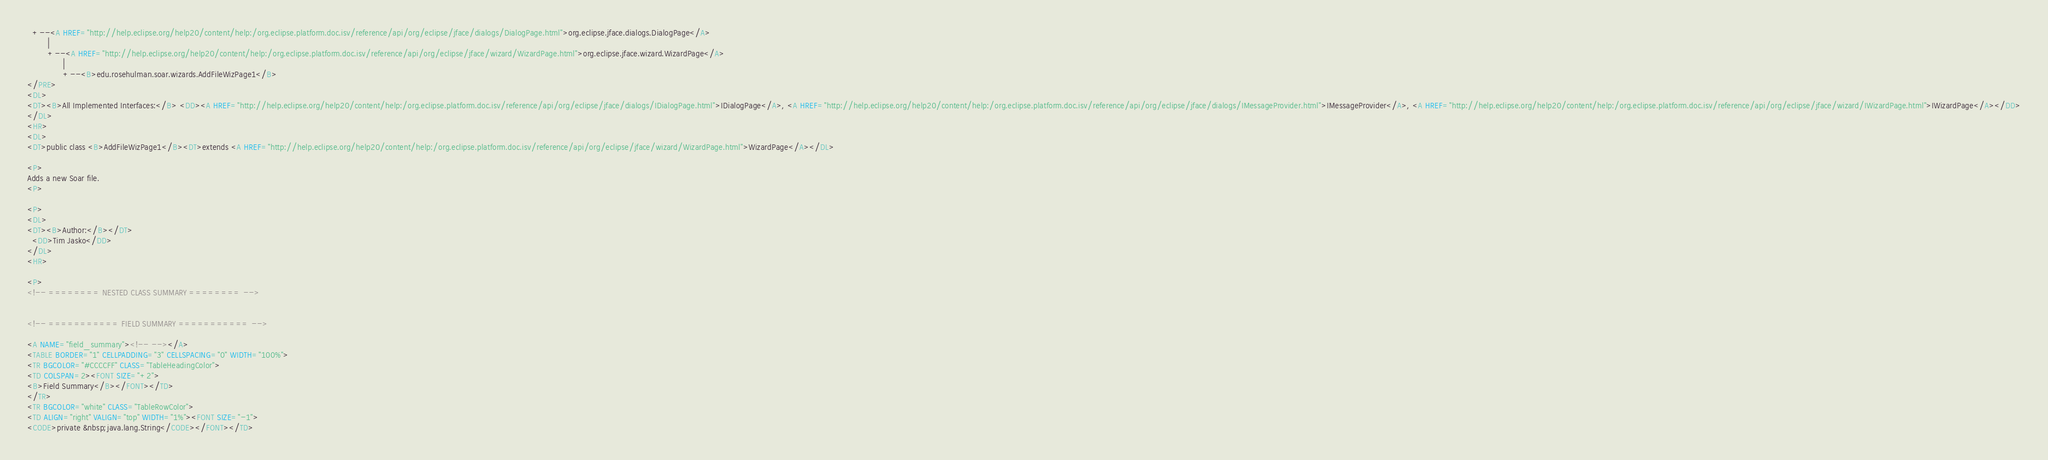<code> <loc_0><loc_0><loc_500><loc_500><_HTML_>  +--<A HREF="http://help.eclipse.org/help20/content/help:/org.eclipse.platform.doc.isv/reference/api/org/eclipse/jface/dialogs/DialogPage.html">org.eclipse.jface.dialogs.DialogPage</A>
        |
        +--<A HREF="http://help.eclipse.org/help20/content/help:/org.eclipse.platform.doc.isv/reference/api/org/eclipse/jface/wizard/WizardPage.html">org.eclipse.jface.wizard.WizardPage</A>
              |
              +--<B>edu.rosehulman.soar.wizards.AddFileWizPage1</B>
</PRE>
<DL>
<DT><B>All Implemented Interfaces:</B> <DD><A HREF="http://help.eclipse.org/help20/content/help:/org.eclipse.platform.doc.isv/reference/api/org/eclipse/jface/dialogs/IDialogPage.html">IDialogPage</A>, <A HREF="http://help.eclipse.org/help20/content/help:/org.eclipse.platform.doc.isv/reference/api/org/eclipse/jface/dialogs/IMessageProvider.html">IMessageProvider</A>, <A HREF="http://help.eclipse.org/help20/content/help:/org.eclipse.platform.doc.isv/reference/api/org/eclipse/jface/wizard/IWizardPage.html">IWizardPage</A></DD>
</DL>
<HR>
<DL>
<DT>public class <B>AddFileWizPage1</B><DT>extends <A HREF="http://help.eclipse.org/help20/content/help:/org.eclipse.platform.doc.isv/reference/api/org/eclipse/jface/wizard/WizardPage.html">WizardPage</A></DL>

<P>
Adds a new Soar file.
<P>

<P>
<DL>
<DT><B>Author:</B></DT>
  <DD>Tim Jasko</DD>
</DL>
<HR>

<P>
<!-- ======== NESTED CLASS SUMMARY ======== -->


<!-- =========== FIELD SUMMARY =========== -->

<A NAME="field_summary"><!-- --></A>
<TABLE BORDER="1" CELLPADDING="3" CELLSPACING="0" WIDTH="100%">
<TR BGCOLOR="#CCCCFF" CLASS="TableHeadingColor">
<TD COLSPAN=2><FONT SIZE="+2">
<B>Field Summary</B></FONT></TD>
</TR>
<TR BGCOLOR="white" CLASS="TableRowColor">
<TD ALIGN="right" VALIGN="top" WIDTH="1%"><FONT SIZE="-1">
<CODE>private &nbsp;java.lang.String</CODE></FONT></TD></code> 